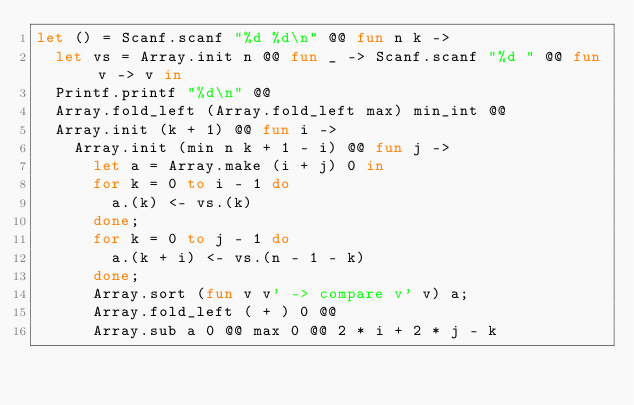Convert code to text. <code><loc_0><loc_0><loc_500><loc_500><_OCaml_>let () = Scanf.scanf "%d %d\n" @@ fun n k ->
  let vs = Array.init n @@ fun _ -> Scanf.scanf "%d " @@ fun v -> v in
  Printf.printf "%d\n" @@
  Array.fold_left (Array.fold_left max) min_int @@
  Array.init (k + 1) @@ fun i ->
    Array.init (min n k + 1 - i) @@ fun j ->
      let a = Array.make (i + j) 0 in
      for k = 0 to i - 1 do
        a.(k) <- vs.(k)
      done;
      for k = 0 to j - 1 do
        a.(k + i) <- vs.(n - 1 - k)
      done;
      Array.sort (fun v v' -> compare v' v) a;
      Array.fold_left ( + ) 0 @@
      Array.sub a 0 @@ max 0 @@ 2 * i + 2 * j - k</code> 